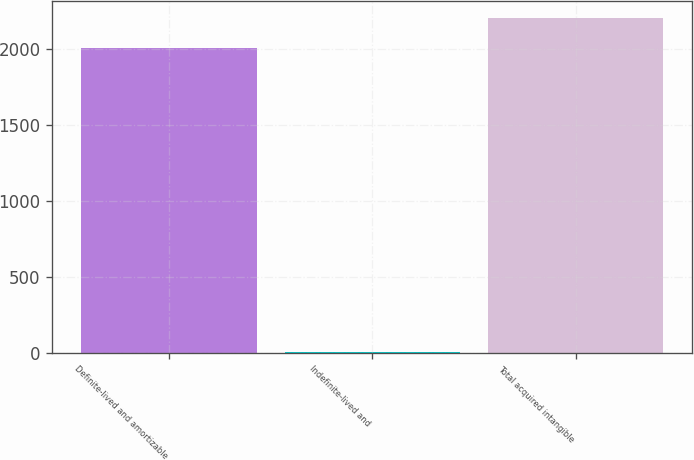Convert chart to OTSL. <chart><loc_0><loc_0><loc_500><loc_500><bar_chart><fcel>Definite-lived and amortizable<fcel>Indefinite-lived and<fcel>Total acquired intangible<nl><fcel>2002<fcel>3.01<fcel>2201.9<nl></chart> 